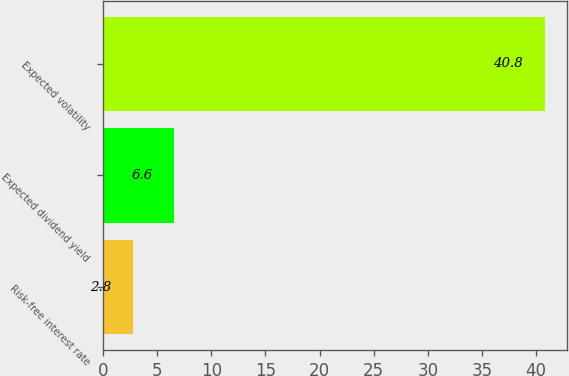Convert chart. <chart><loc_0><loc_0><loc_500><loc_500><bar_chart><fcel>Risk-free interest rate<fcel>Expected dividend yield<fcel>Expected volatility<nl><fcel>2.8<fcel>6.6<fcel>40.8<nl></chart> 